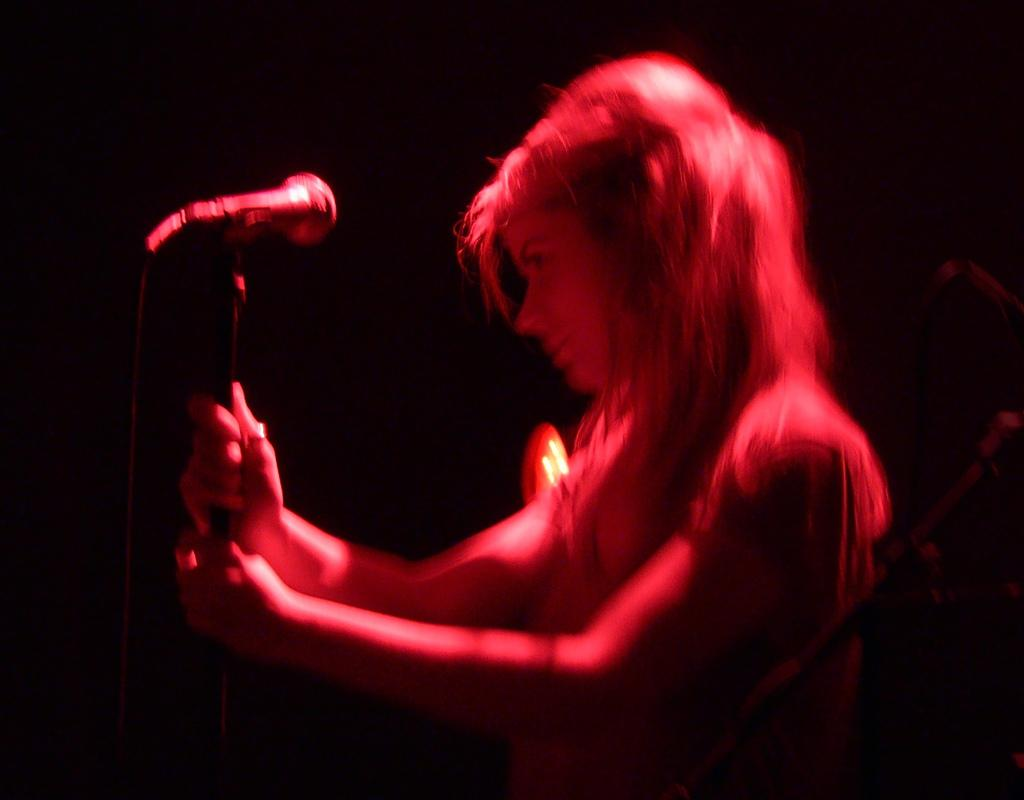Who is the main subject in the image? There is a lady in the image. What is the lady holding in the image? The lady is holding a mic stand. What is in front of the lady? There is a mic with a mic stand in front of the lady. How would you describe the background of the image? The background of the image is dark. What is the lady's preferred skate route in the image? There is no mention of skating or a route in the image; the lady is holding a mic stand. 